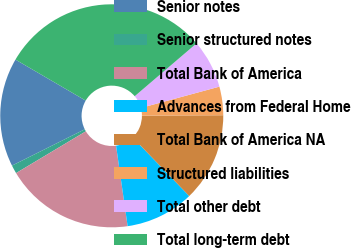<chart> <loc_0><loc_0><loc_500><loc_500><pie_chart><fcel>Senior notes<fcel>Senior structured notes<fcel>Total Bank of America<fcel>Advances from Federal Home<fcel>Total Bank of America NA<fcel>Structured liabilities<fcel>Total other debt<fcel>Total long-term debt<nl><fcel>15.78%<fcel>1.22%<fcel>18.69%<fcel>9.95%<fcel>12.86%<fcel>4.13%<fcel>7.04%<fcel>30.34%<nl></chart> 